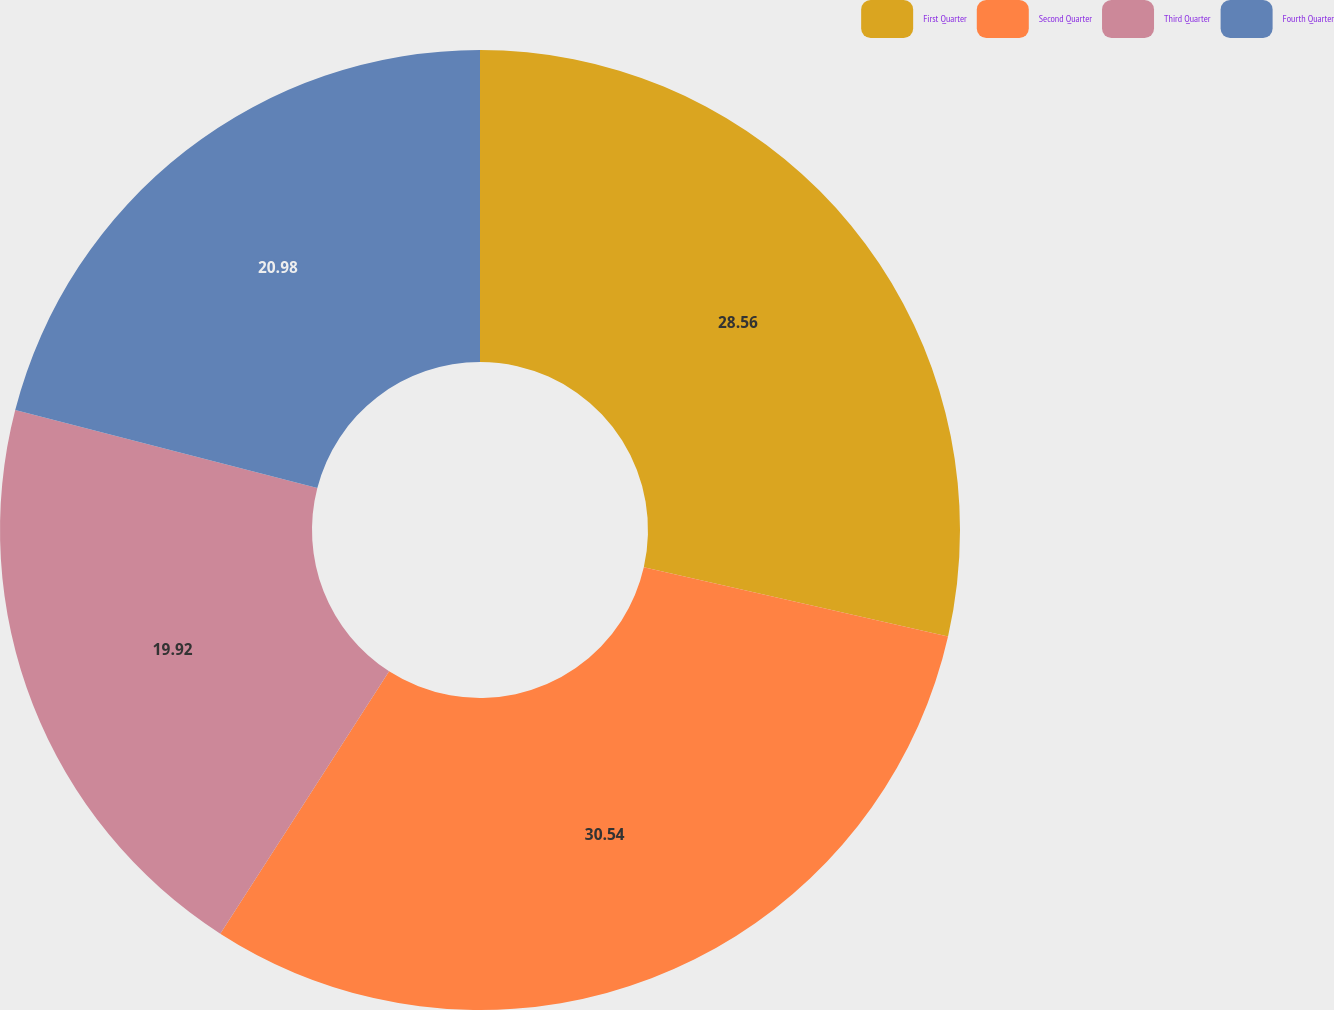Convert chart to OTSL. <chart><loc_0><loc_0><loc_500><loc_500><pie_chart><fcel>First Quarter<fcel>Second Quarter<fcel>Third Quarter<fcel>Fourth Quarter<nl><fcel>28.56%<fcel>30.54%<fcel>19.92%<fcel>20.98%<nl></chart> 